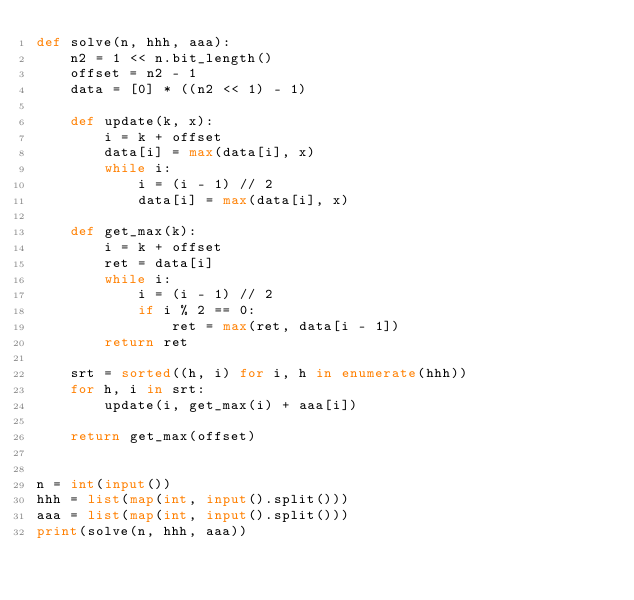Convert code to text. <code><loc_0><loc_0><loc_500><loc_500><_Python_>def solve(n, hhh, aaa):
    n2 = 1 << n.bit_length()
    offset = n2 - 1
    data = [0] * ((n2 << 1) - 1)

    def update(k, x):
        i = k + offset
        data[i] = max(data[i], x)
        while i:
            i = (i - 1) // 2
            data[i] = max(data[i], x)

    def get_max(k):
        i = k + offset
        ret = data[i]
        while i:
            i = (i - 1) // 2
            if i % 2 == 0:
                ret = max(ret, data[i - 1])
        return ret

    srt = sorted((h, i) for i, h in enumerate(hhh))
    for h, i in srt:
        update(i, get_max(i) + aaa[i])

    return get_max(offset)


n = int(input())
hhh = list(map(int, input().split()))
aaa = list(map(int, input().split()))
print(solve(n, hhh, aaa))
</code> 